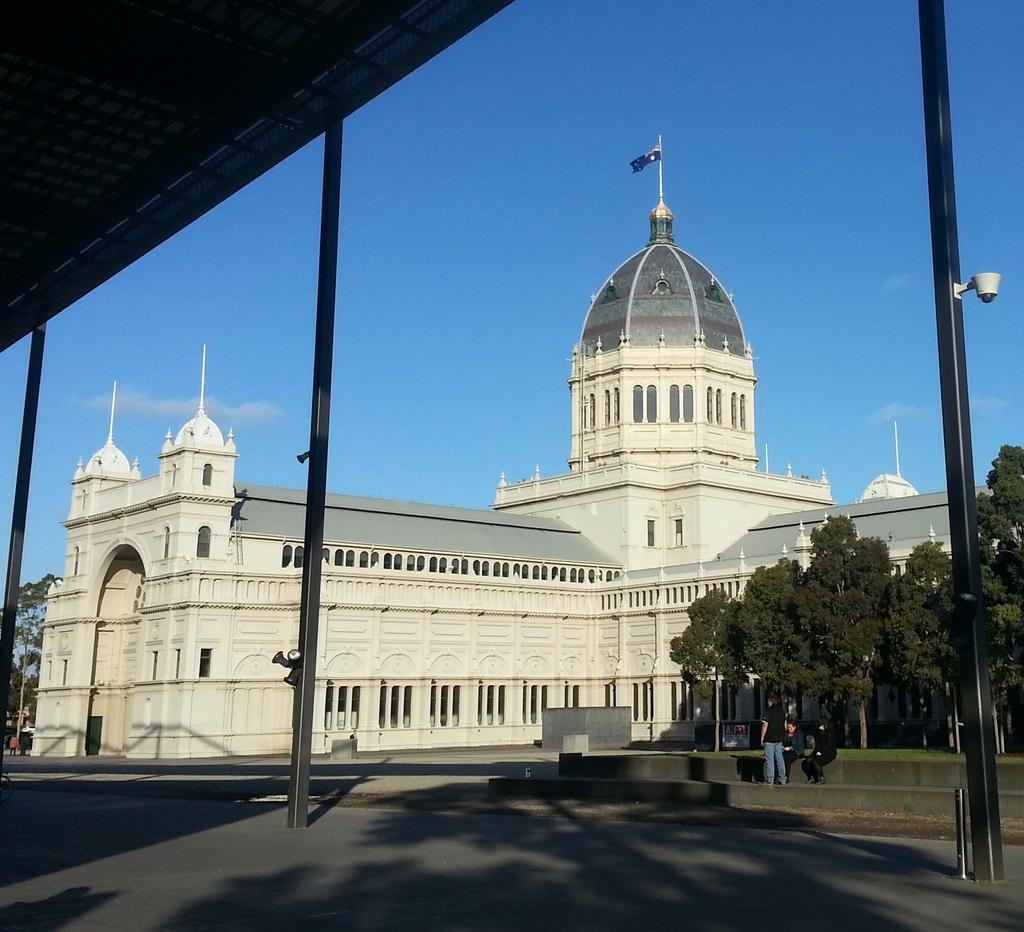What type of structure is visible in the image? There is a building with windows in the image. What can be seen flying near the building? There is a flag in the image. What type of natural elements are present in the image? There are trees in the image. Who or what is present in the image? There are people in the image. What is the color of the sky in the image? The sky is blue in the image. What type of magic is being performed by the people in the image? There is no indication of magic or any magical activity in the image. What type of brush is being used by the trees in the image? Trees are natural elements and do not use brushes. 